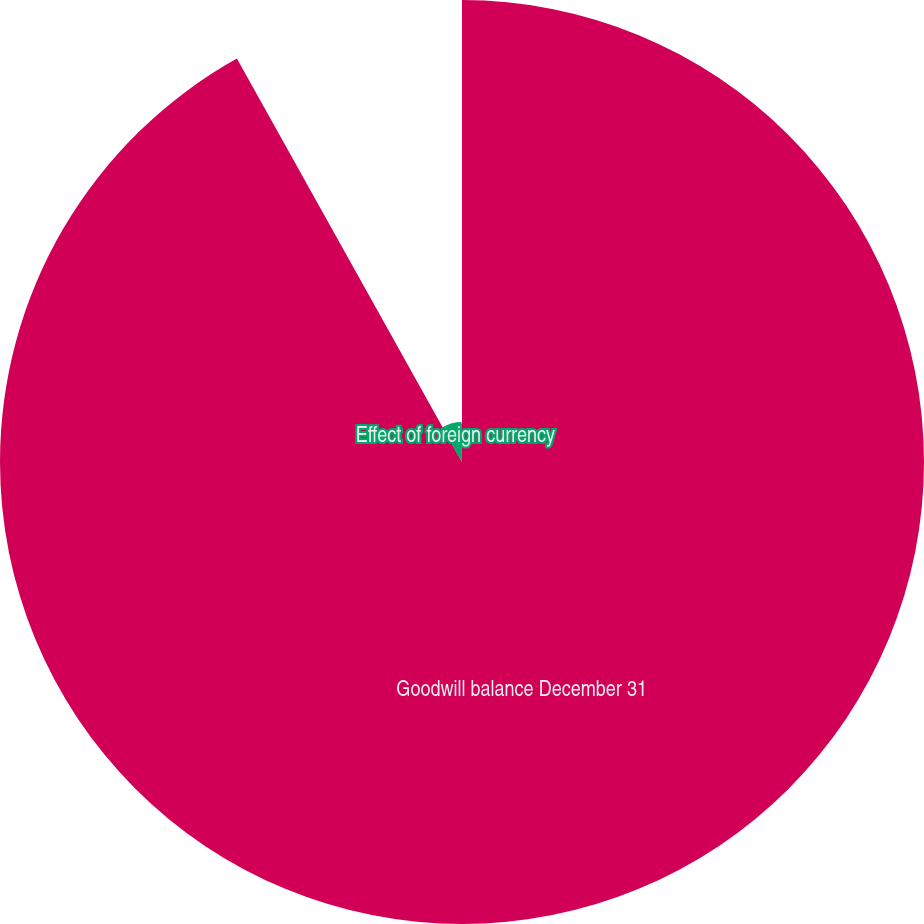Convert chart to OTSL. <chart><loc_0><loc_0><loc_500><loc_500><pie_chart><fcel>Goodwill balance December 31<fcel>Effect of foreign currency<fcel>Acquisitions<nl><fcel>91.9%<fcel>7.94%<fcel>0.16%<nl></chart> 